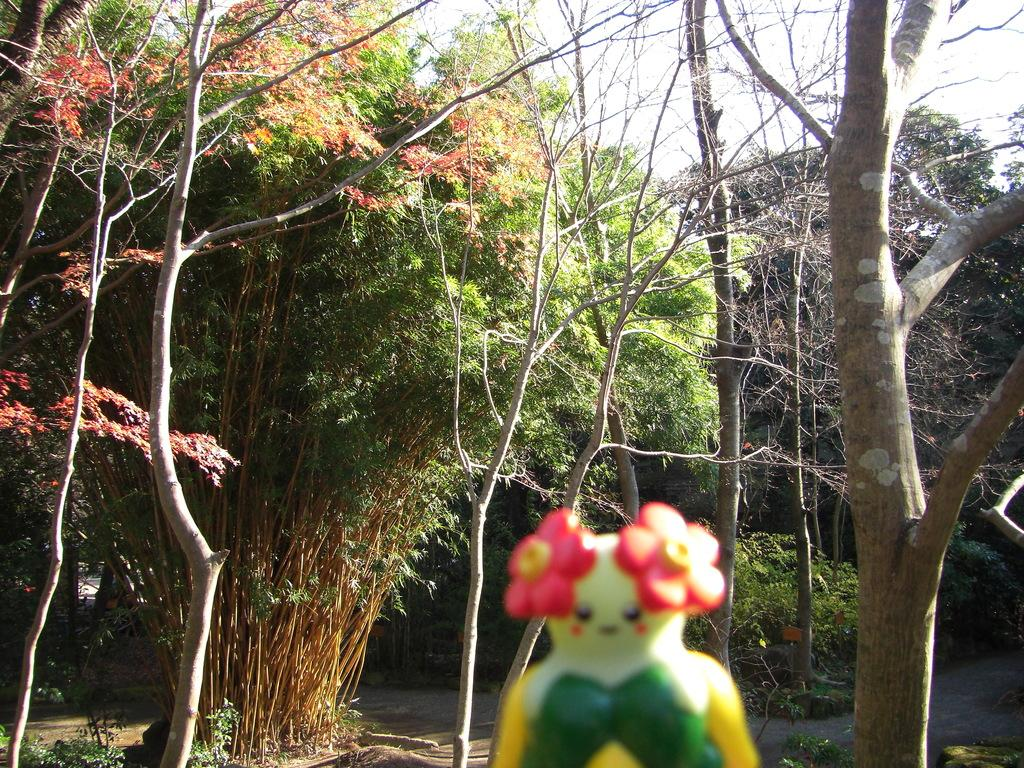What object in the image resembles a toy? There is a toy in the image. What type of natural scenery can be seen in the background of the image? There are trees in the background of the image. What part of the natural environment is visible in the image? The sky is visible in the background of the image. What type of business is being conducted by the grandmother in the image? There is no grandmother or business present in the image. How does the edge of the toy appear in the image? The edge of the toy is not mentioned in the provided facts, so it cannot be described. 